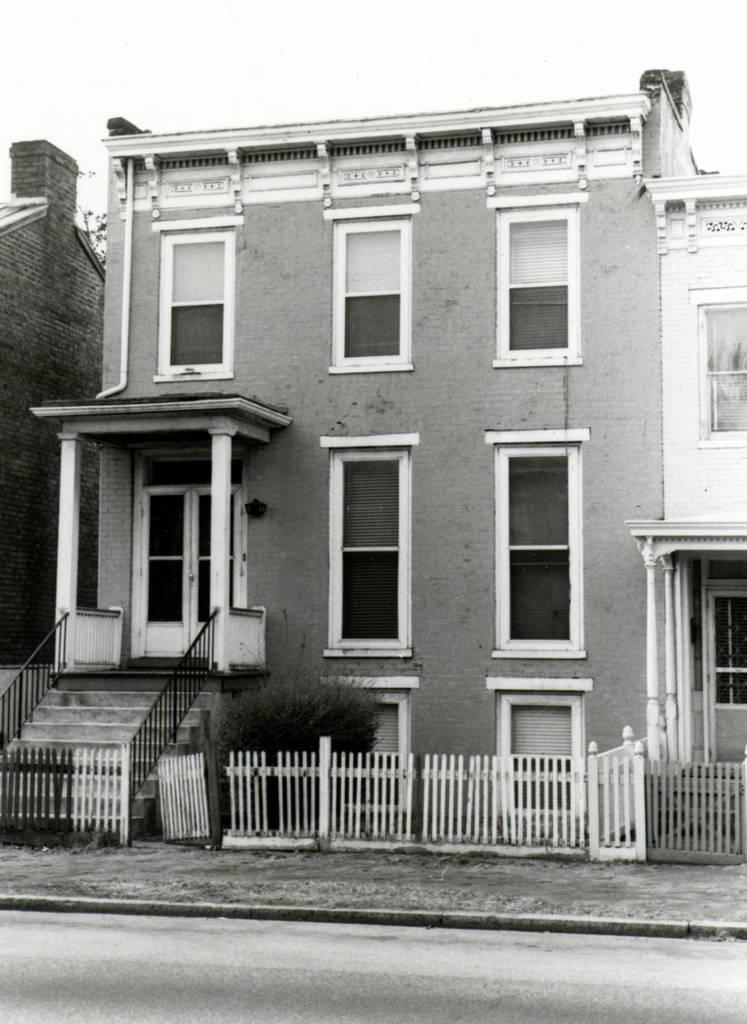What is the color scheme of the image? The image is black and white. What type of structures can be seen in the image? There are buildings in the image. Can you describe any architectural features in the image? Yes, there are pillars, stairs, and staircase holders visible in the image. What type of barrier is present in the image? There is fencing in the image. What can be seen in the background of the image? The sky is visible in the background of the image. What type of holiday is being celebrated in the image? There is no indication of a holiday being celebrated in the image, as it primarily features buildings, pillars, stairs, and other architectural elements. Can you see any thread or hose in the image? No, there is no thread or hose present in the image. 